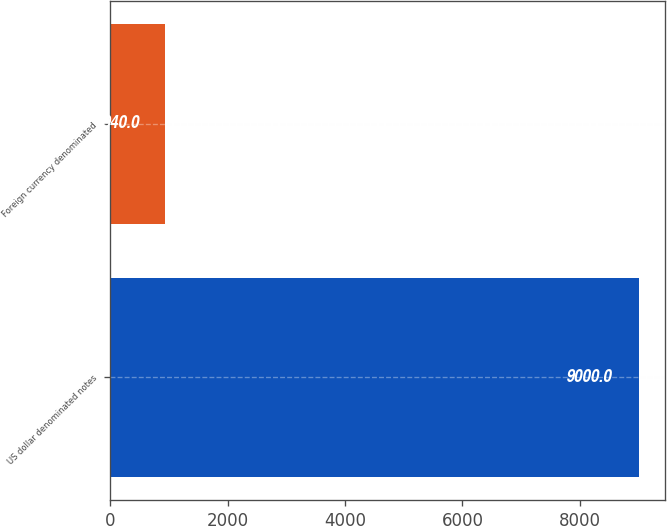<chart> <loc_0><loc_0><loc_500><loc_500><bar_chart><fcel>US dollar denominated notes<fcel>Foreign currency denominated<nl><fcel>9000<fcel>940<nl></chart> 